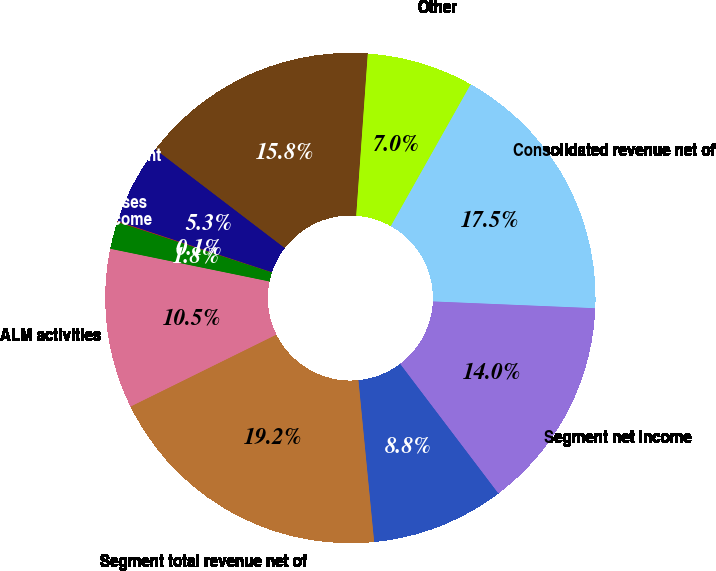Convert chart. <chart><loc_0><loc_0><loc_500><loc_500><pie_chart><fcel>(Dollars in millions)<fcel>Segment total revenue net of<fcel>ALM activities<fcel>Equity investment income<fcel>Liquidating businesses<fcel>FTE basis adjustment<fcel>Managed securitization impact<fcel>Other<fcel>Consolidated revenue net of<fcel>Segment net income<nl><fcel>8.78%<fcel>19.25%<fcel>10.52%<fcel>1.8%<fcel>0.06%<fcel>5.29%<fcel>15.76%<fcel>7.03%<fcel>17.5%<fcel>14.01%<nl></chart> 